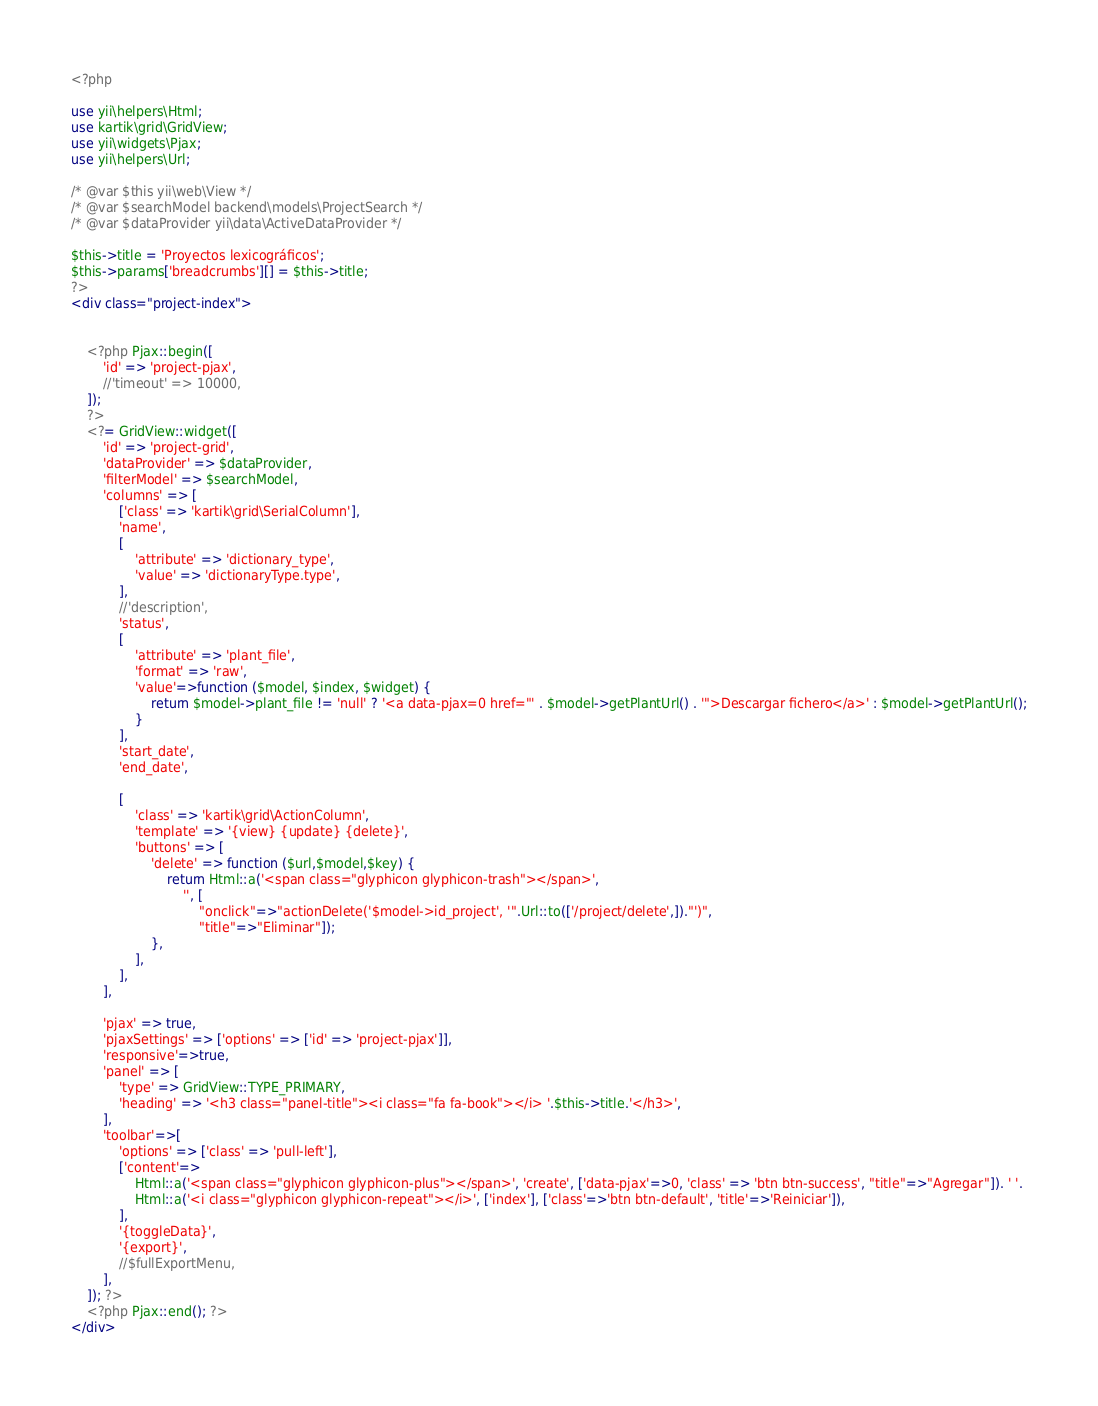Convert code to text. <code><loc_0><loc_0><loc_500><loc_500><_PHP_><?php

use yii\helpers\Html;
use kartik\grid\GridView;
use yii\widgets\Pjax;
use yii\helpers\Url;

/* @var $this yii\web\View */
/* @var $searchModel backend\models\ProjectSearch */
/* @var $dataProvider yii\data\ActiveDataProvider */

$this->title = 'Proyectos lexicográficos';
$this->params['breadcrumbs'][] = $this->title;
?>
<div class="project-index">


    <?php Pjax::begin([
        'id' => 'project-pjax',
        //'timeout' => 10000,
    ]);
    ?>
    <?= GridView::widget([
        'id' => 'project-grid',
        'dataProvider' => $dataProvider,
        'filterModel' => $searchModel,
        'columns' => [
            ['class' => 'kartik\grid\SerialColumn'],
            'name',
            [
                'attribute' => 'dictionary_type',
                'value' => 'dictionaryType.type',
            ],
            //'description',
            'status',
            [
                'attribute' => 'plant_file',
                'format' => 'raw',
                'value'=>function ($model, $index, $widget) {
                    return $model->plant_file != 'null' ? '<a data-pjax=0 href="' . $model->getPlantUrl() . '">Descargar fichero</a>' : $model->getPlantUrl();
                }
            ],
            'start_date',
            'end_date',

            [
                'class' => 'kartik\grid\ActionColumn',
                'template' => '{view} {update} {delete}',
                'buttons' => [
                    'delete' => function ($url,$model,$key) {
                        return Html::a('<span class="glyphicon glyphicon-trash"></span>',
                            '', [
                                "onclick"=>"actionDelete('$model->id_project', '".Url::to(['/project/delete',])."')",
                                "title"=>"Eliminar"]);
                    },
                ],
            ],
        ],

        'pjax' => true,
        'pjaxSettings' => ['options' => ['id' => 'project-pjax']],
        'responsive'=>true,
        'panel' => [
            'type' => GridView::TYPE_PRIMARY,
            'heading' => '<h3 class="panel-title"><i class="fa fa-book"></i> '.$this->title.'</h3>',
        ],
        'toolbar'=>[
            'options' => ['class' => 'pull-left'],
            ['content'=>
                Html::a('<span class="glyphicon glyphicon-plus"></span>', 'create', ['data-pjax'=>0, 'class' => 'btn btn-success', "title"=>"Agregar"]). ' '.
                Html::a('<i class="glyphicon glyphicon-repeat"></i>', ['index'], ['class'=>'btn btn-default', 'title'=>'Reiniciar']),
            ],
            '{toggleData}',
            '{export}',
            //$fullExportMenu,
        ],
    ]); ?>
    <?php Pjax::end(); ?>
</div>
</code> 